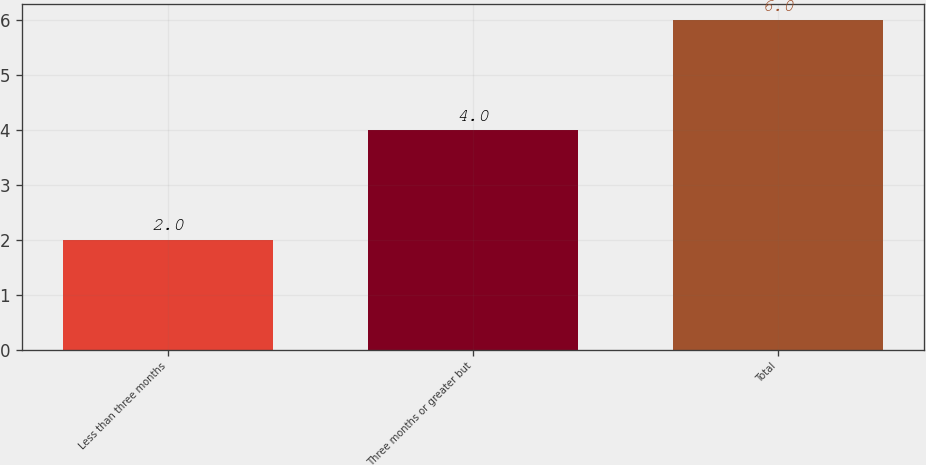Convert chart. <chart><loc_0><loc_0><loc_500><loc_500><bar_chart><fcel>Less than three months<fcel>Three months or greater but<fcel>Total<nl><fcel>2<fcel>4<fcel>6<nl></chart> 